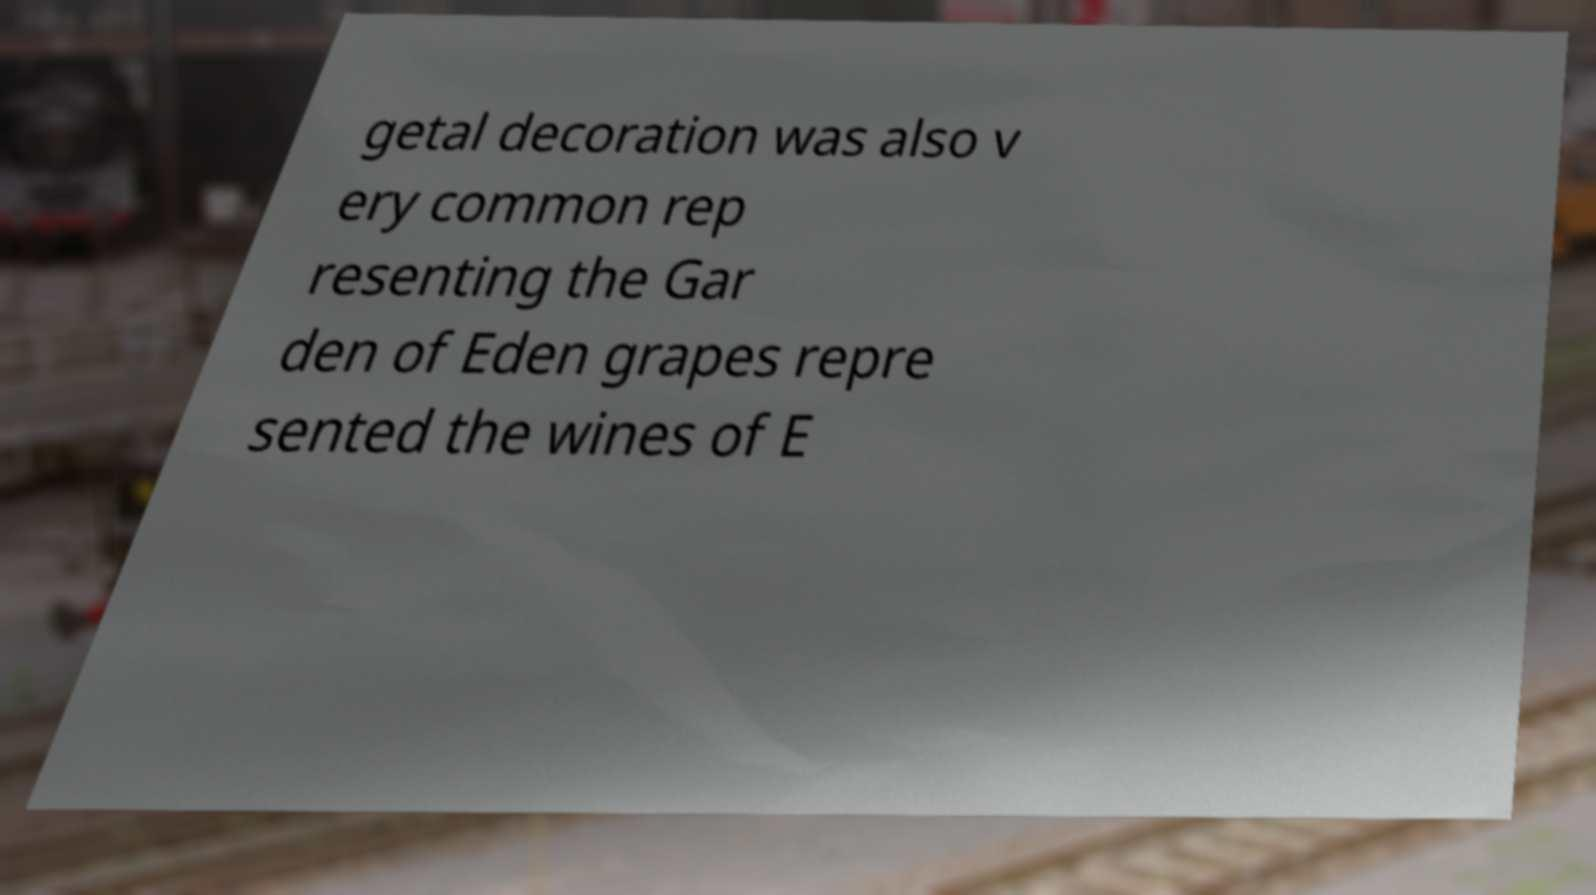For documentation purposes, I need the text within this image transcribed. Could you provide that? getal decoration was also v ery common rep resenting the Gar den of Eden grapes repre sented the wines of E 